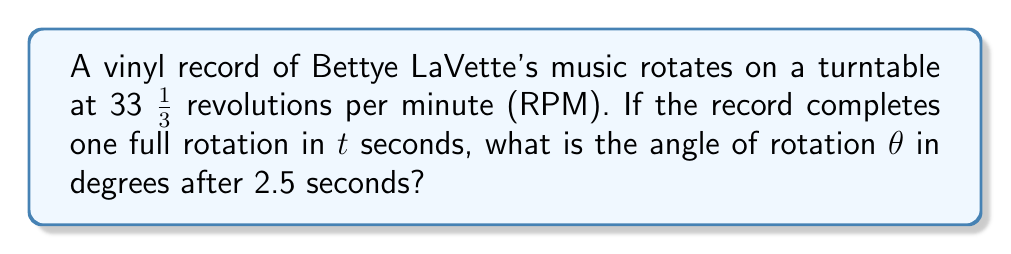Show me your answer to this math problem. Let's approach this step-by-step:

1) First, we need to find how long it takes for one complete rotation:
   $$ 33\frac{1}{3} \text{ rotations} = 60 \text{ seconds} $$
   $$ 1 \text{ rotation} = \frac{60}{33\frac{1}{3}} = 1.8 \text{ seconds} $$

2) We know that one complete rotation is 360°. So we can set up a proportion:
   $$ \frac{360°}{1.8 \text{ seconds}} = \frac{\theta}{2.5 \text{ seconds}} $$

3) Cross multiply:
   $$ 360 \cdot 2.5 = 1.8\theta $$

4) Solve for $\theta$:
   $$ \theta = \frac{360 \cdot 2.5}{1.8} = 500° $$

5) However, since we're dealing with a rotation, we should express this as an angle between 0° and 360°. We can do this by subtracting 360° from our result:
   $$ 500° - 360° = 140° $$

Therefore, after 2.5 seconds, the vinyl record will have rotated 140°.
Answer: 140° 